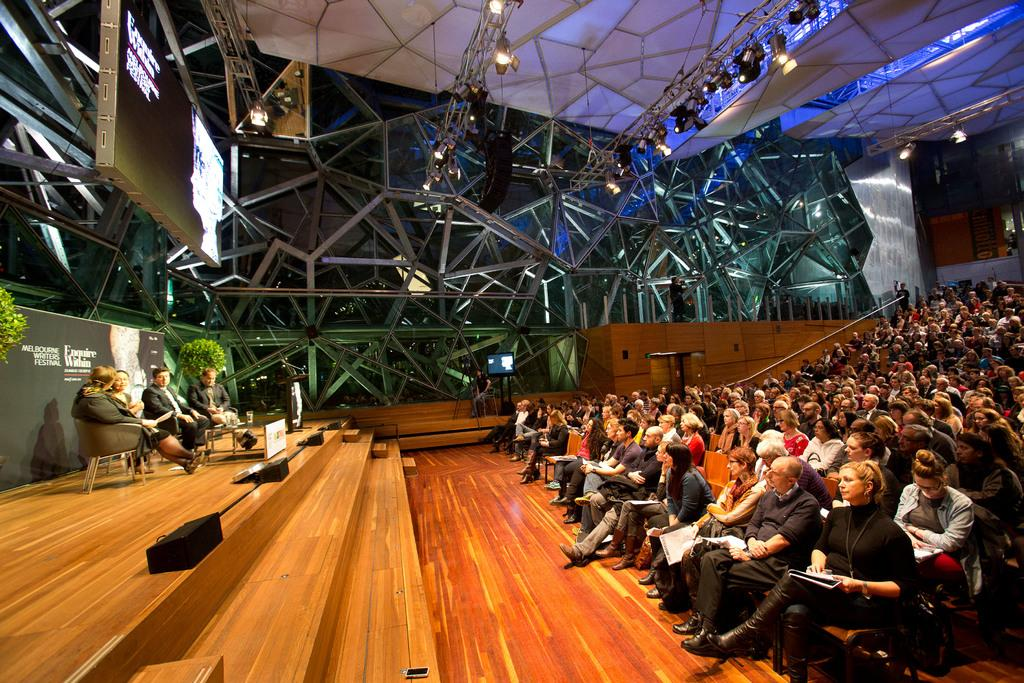What type of space is depicted in the image? There is a big hall in the image. What are the people in the hall doing? There are people sitting on chairs in the hall. Are there any people on a stage in the hall? Yes, there are four people sitting on a stage in the hall. What type of roll is being served to the people in the image? There is no roll present in the image; it only shows a big hall with people sitting on chairs and four people on a stage. 